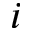<formula> <loc_0><loc_0><loc_500><loc_500>i</formula> 